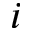<formula> <loc_0><loc_0><loc_500><loc_500>i</formula> 